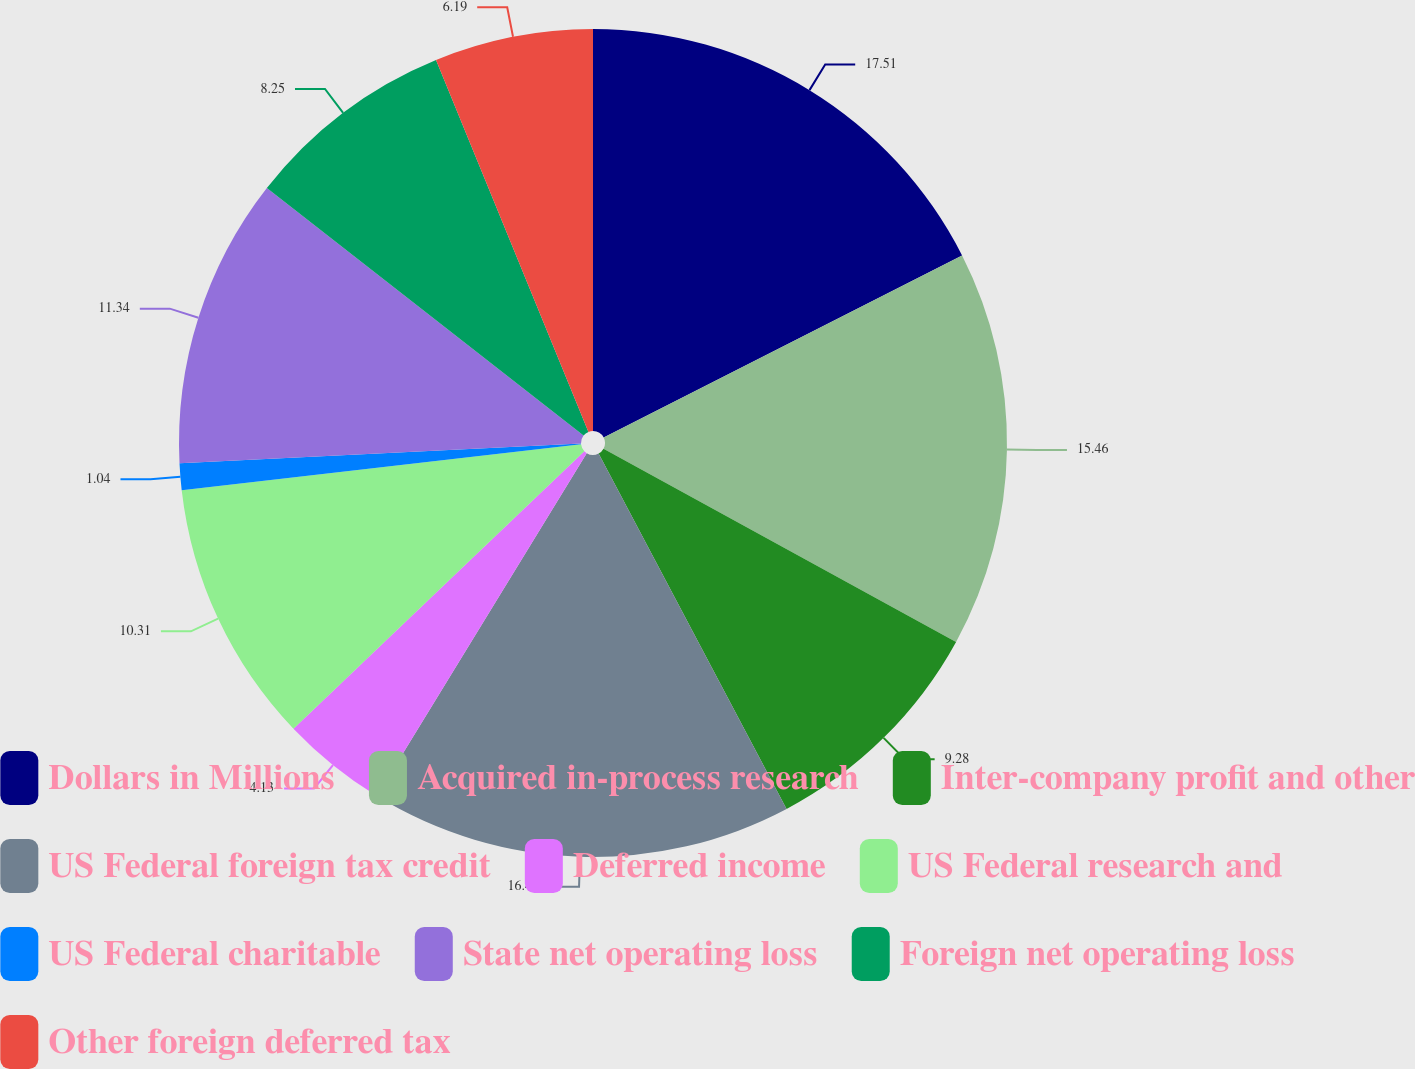Convert chart to OTSL. <chart><loc_0><loc_0><loc_500><loc_500><pie_chart><fcel>Dollars in Millions<fcel>Acquired in-process research<fcel>Inter-company profit and other<fcel>US Federal foreign tax credit<fcel>Deferred income<fcel>US Federal research and<fcel>US Federal charitable<fcel>State net operating loss<fcel>Foreign net operating loss<fcel>Other foreign deferred tax<nl><fcel>17.52%<fcel>15.46%<fcel>9.28%<fcel>16.49%<fcel>4.13%<fcel>10.31%<fcel>1.04%<fcel>11.34%<fcel>8.25%<fcel>6.19%<nl></chart> 